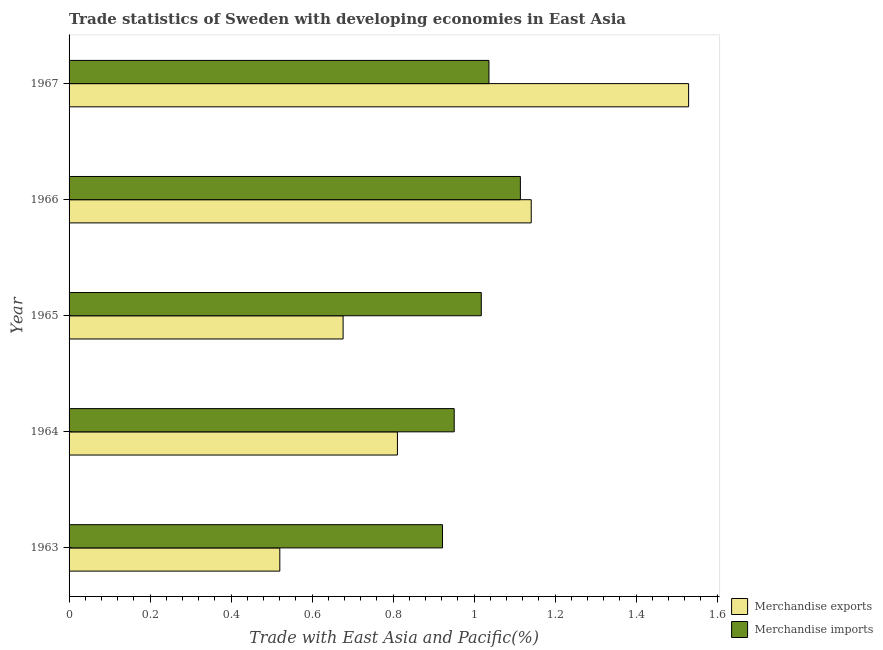Are the number of bars per tick equal to the number of legend labels?
Offer a terse response. Yes. Are the number of bars on each tick of the Y-axis equal?
Ensure brevity in your answer.  Yes. How many bars are there on the 4th tick from the top?
Give a very brief answer. 2. How many bars are there on the 2nd tick from the bottom?
Offer a terse response. 2. What is the label of the 3rd group of bars from the top?
Offer a terse response. 1965. What is the merchandise imports in 1966?
Your response must be concise. 1.11. Across all years, what is the maximum merchandise imports?
Provide a succinct answer. 1.11. Across all years, what is the minimum merchandise imports?
Make the answer very short. 0.92. In which year was the merchandise exports maximum?
Ensure brevity in your answer.  1967. What is the total merchandise exports in the graph?
Give a very brief answer. 4.68. What is the difference between the merchandise exports in 1964 and that in 1967?
Provide a succinct answer. -0.72. What is the difference between the merchandise imports in 1967 and the merchandise exports in 1963?
Make the answer very short. 0.52. What is the average merchandise exports per year?
Make the answer very short. 0.94. In the year 1964, what is the difference between the merchandise exports and merchandise imports?
Keep it short and to the point. -0.14. In how many years, is the merchandise imports greater than 0.4 %?
Your response must be concise. 5. What is the ratio of the merchandise exports in 1963 to that in 1966?
Ensure brevity in your answer.  0.46. Is the difference between the merchandise imports in 1963 and 1964 greater than the difference between the merchandise exports in 1963 and 1964?
Make the answer very short. Yes. What is the difference between the highest and the second highest merchandise imports?
Offer a terse response. 0.08. Is the sum of the merchandise imports in 1964 and 1967 greater than the maximum merchandise exports across all years?
Your answer should be very brief. Yes. What does the 2nd bar from the top in 1967 represents?
Your answer should be very brief. Merchandise exports. What does the 1st bar from the bottom in 1967 represents?
Provide a short and direct response. Merchandise exports. How many years are there in the graph?
Ensure brevity in your answer.  5. Does the graph contain grids?
Your answer should be compact. No. Where does the legend appear in the graph?
Offer a very short reply. Bottom right. How are the legend labels stacked?
Provide a succinct answer. Vertical. What is the title of the graph?
Your response must be concise. Trade statistics of Sweden with developing economies in East Asia. Does "Urban Population" appear as one of the legend labels in the graph?
Make the answer very short. No. What is the label or title of the X-axis?
Provide a short and direct response. Trade with East Asia and Pacific(%). What is the label or title of the Y-axis?
Your answer should be very brief. Year. What is the Trade with East Asia and Pacific(%) of Merchandise exports in 1963?
Offer a terse response. 0.52. What is the Trade with East Asia and Pacific(%) in Merchandise imports in 1963?
Give a very brief answer. 0.92. What is the Trade with East Asia and Pacific(%) in Merchandise exports in 1964?
Keep it short and to the point. 0.81. What is the Trade with East Asia and Pacific(%) in Merchandise imports in 1964?
Offer a terse response. 0.95. What is the Trade with East Asia and Pacific(%) in Merchandise exports in 1965?
Offer a terse response. 0.68. What is the Trade with East Asia and Pacific(%) of Merchandise imports in 1965?
Your answer should be compact. 1.02. What is the Trade with East Asia and Pacific(%) of Merchandise exports in 1966?
Provide a succinct answer. 1.14. What is the Trade with East Asia and Pacific(%) of Merchandise imports in 1966?
Offer a terse response. 1.11. What is the Trade with East Asia and Pacific(%) of Merchandise exports in 1967?
Make the answer very short. 1.53. What is the Trade with East Asia and Pacific(%) in Merchandise imports in 1967?
Offer a very short reply. 1.04. Across all years, what is the maximum Trade with East Asia and Pacific(%) in Merchandise exports?
Provide a succinct answer. 1.53. Across all years, what is the maximum Trade with East Asia and Pacific(%) of Merchandise imports?
Give a very brief answer. 1.11. Across all years, what is the minimum Trade with East Asia and Pacific(%) in Merchandise exports?
Keep it short and to the point. 0.52. Across all years, what is the minimum Trade with East Asia and Pacific(%) of Merchandise imports?
Your answer should be compact. 0.92. What is the total Trade with East Asia and Pacific(%) of Merchandise exports in the graph?
Provide a short and direct response. 4.68. What is the total Trade with East Asia and Pacific(%) of Merchandise imports in the graph?
Give a very brief answer. 5.04. What is the difference between the Trade with East Asia and Pacific(%) of Merchandise exports in 1963 and that in 1964?
Provide a succinct answer. -0.29. What is the difference between the Trade with East Asia and Pacific(%) of Merchandise imports in 1963 and that in 1964?
Make the answer very short. -0.03. What is the difference between the Trade with East Asia and Pacific(%) in Merchandise exports in 1963 and that in 1965?
Give a very brief answer. -0.16. What is the difference between the Trade with East Asia and Pacific(%) of Merchandise imports in 1963 and that in 1965?
Your answer should be very brief. -0.1. What is the difference between the Trade with East Asia and Pacific(%) of Merchandise exports in 1963 and that in 1966?
Ensure brevity in your answer.  -0.62. What is the difference between the Trade with East Asia and Pacific(%) in Merchandise imports in 1963 and that in 1966?
Give a very brief answer. -0.19. What is the difference between the Trade with East Asia and Pacific(%) in Merchandise exports in 1963 and that in 1967?
Your answer should be compact. -1.01. What is the difference between the Trade with East Asia and Pacific(%) of Merchandise imports in 1963 and that in 1967?
Provide a short and direct response. -0.11. What is the difference between the Trade with East Asia and Pacific(%) of Merchandise exports in 1964 and that in 1965?
Your response must be concise. 0.13. What is the difference between the Trade with East Asia and Pacific(%) in Merchandise imports in 1964 and that in 1965?
Ensure brevity in your answer.  -0.07. What is the difference between the Trade with East Asia and Pacific(%) of Merchandise exports in 1964 and that in 1966?
Provide a short and direct response. -0.33. What is the difference between the Trade with East Asia and Pacific(%) of Merchandise imports in 1964 and that in 1966?
Offer a very short reply. -0.16. What is the difference between the Trade with East Asia and Pacific(%) of Merchandise exports in 1964 and that in 1967?
Your answer should be very brief. -0.72. What is the difference between the Trade with East Asia and Pacific(%) of Merchandise imports in 1964 and that in 1967?
Provide a short and direct response. -0.09. What is the difference between the Trade with East Asia and Pacific(%) of Merchandise exports in 1965 and that in 1966?
Make the answer very short. -0.46. What is the difference between the Trade with East Asia and Pacific(%) of Merchandise imports in 1965 and that in 1966?
Provide a short and direct response. -0.1. What is the difference between the Trade with East Asia and Pacific(%) of Merchandise exports in 1965 and that in 1967?
Provide a succinct answer. -0.85. What is the difference between the Trade with East Asia and Pacific(%) of Merchandise imports in 1965 and that in 1967?
Ensure brevity in your answer.  -0.02. What is the difference between the Trade with East Asia and Pacific(%) of Merchandise exports in 1966 and that in 1967?
Provide a short and direct response. -0.39. What is the difference between the Trade with East Asia and Pacific(%) of Merchandise imports in 1966 and that in 1967?
Make the answer very short. 0.08. What is the difference between the Trade with East Asia and Pacific(%) of Merchandise exports in 1963 and the Trade with East Asia and Pacific(%) of Merchandise imports in 1964?
Ensure brevity in your answer.  -0.43. What is the difference between the Trade with East Asia and Pacific(%) in Merchandise exports in 1963 and the Trade with East Asia and Pacific(%) in Merchandise imports in 1965?
Keep it short and to the point. -0.5. What is the difference between the Trade with East Asia and Pacific(%) of Merchandise exports in 1963 and the Trade with East Asia and Pacific(%) of Merchandise imports in 1966?
Make the answer very short. -0.59. What is the difference between the Trade with East Asia and Pacific(%) of Merchandise exports in 1963 and the Trade with East Asia and Pacific(%) of Merchandise imports in 1967?
Provide a succinct answer. -0.52. What is the difference between the Trade with East Asia and Pacific(%) in Merchandise exports in 1964 and the Trade with East Asia and Pacific(%) in Merchandise imports in 1965?
Provide a succinct answer. -0.21. What is the difference between the Trade with East Asia and Pacific(%) of Merchandise exports in 1964 and the Trade with East Asia and Pacific(%) of Merchandise imports in 1966?
Provide a short and direct response. -0.3. What is the difference between the Trade with East Asia and Pacific(%) of Merchandise exports in 1964 and the Trade with East Asia and Pacific(%) of Merchandise imports in 1967?
Ensure brevity in your answer.  -0.23. What is the difference between the Trade with East Asia and Pacific(%) in Merchandise exports in 1965 and the Trade with East Asia and Pacific(%) in Merchandise imports in 1966?
Provide a short and direct response. -0.44. What is the difference between the Trade with East Asia and Pacific(%) in Merchandise exports in 1965 and the Trade with East Asia and Pacific(%) in Merchandise imports in 1967?
Offer a very short reply. -0.36. What is the difference between the Trade with East Asia and Pacific(%) of Merchandise exports in 1966 and the Trade with East Asia and Pacific(%) of Merchandise imports in 1967?
Offer a very short reply. 0.1. What is the average Trade with East Asia and Pacific(%) in Merchandise exports per year?
Provide a short and direct response. 0.94. What is the average Trade with East Asia and Pacific(%) in Merchandise imports per year?
Offer a terse response. 1.01. In the year 1963, what is the difference between the Trade with East Asia and Pacific(%) in Merchandise exports and Trade with East Asia and Pacific(%) in Merchandise imports?
Provide a succinct answer. -0.4. In the year 1964, what is the difference between the Trade with East Asia and Pacific(%) of Merchandise exports and Trade with East Asia and Pacific(%) of Merchandise imports?
Give a very brief answer. -0.14. In the year 1965, what is the difference between the Trade with East Asia and Pacific(%) of Merchandise exports and Trade with East Asia and Pacific(%) of Merchandise imports?
Offer a terse response. -0.34. In the year 1966, what is the difference between the Trade with East Asia and Pacific(%) in Merchandise exports and Trade with East Asia and Pacific(%) in Merchandise imports?
Offer a very short reply. 0.03. In the year 1967, what is the difference between the Trade with East Asia and Pacific(%) in Merchandise exports and Trade with East Asia and Pacific(%) in Merchandise imports?
Offer a terse response. 0.49. What is the ratio of the Trade with East Asia and Pacific(%) in Merchandise exports in 1963 to that in 1964?
Provide a succinct answer. 0.64. What is the ratio of the Trade with East Asia and Pacific(%) in Merchandise imports in 1963 to that in 1964?
Make the answer very short. 0.97. What is the ratio of the Trade with East Asia and Pacific(%) in Merchandise exports in 1963 to that in 1965?
Provide a short and direct response. 0.77. What is the ratio of the Trade with East Asia and Pacific(%) in Merchandise imports in 1963 to that in 1965?
Give a very brief answer. 0.91. What is the ratio of the Trade with East Asia and Pacific(%) of Merchandise exports in 1963 to that in 1966?
Your response must be concise. 0.46. What is the ratio of the Trade with East Asia and Pacific(%) in Merchandise imports in 1963 to that in 1966?
Make the answer very short. 0.83. What is the ratio of the Trade with East Asia and Pacific(%) of Merchandise exports in 1963 to that in 1967?
Make the answer very short. 0.34. What is the ratio of the Trade with East Asia and Pacific(%) of Merchandise imports in 1963 to that in 1967?
Your answer should be very brief. 0.89. What is the ratio of the Trade with East Asia and Pacific(%) in Merchandise exports in 1964 to that in 1965?
Keep it short and to the point. 1.2. What is the ratio of the Trade with East Asia and Pacific(%) of Merchandise imports in 1964 to that in 1965?
Your answer should be compact. 0.93. What is the ratio of the Trade with East Asia and Pacific(%) of Merchandise exports in 1964 to that in 1966?
Provide a short and direct response. 0.71. What is the ratio of the Trade with East Asia and Pacific(%) of Merchandise imports in 1964 to that in 1966?
Offer a terse response. 0.85. What is the ratio of the Trade with East Asia and Pacific(%) of Merchandise exports in 1964 to that in 1967?
Your answer should be compact. 0.53. What is the ratio of the Trade with East Asia and Pacific(%) of Merchandise imports in 1964 to that in 1967?
Your answer should be compact. 0.92. What is the ratio of the Trade with East Asia and Pacific(%) in Merchandise exports in 1965 to that in 1966?
Ensure brevity in your answer.  0.59. What is the ratio of the Trade with East Asia and Pacific(%) in Merchandise imports in 1965 to that in 1966?
Keep it short and to the point. 0.91. What is the ratio of the Trade with East Asia and Pacific(%) of Merchandise exports in 1965 to that in 1967?
Provide a succinct answer. 0.44. What is the ratio of the Trade with East Asia and Pacific(%) in Merchandise imports in 1965 to that in 1967?
Ensure brevity in your answer.  0.98. What is the ratio of the Trade with East Asia and Pacific(%) of Merchandise exports in 1966 to that in 1967?
Keep it short and to the point. 0.75. What is the ratio of the Trade with East Asia and Pacific(%) of Merchandise imports in 1966 to that in 1967?
Offer a terse response. 1.07. What is the difference between the highest and the second highest Trade with East Asia and Pacific(%) in Merchandise exports?
Ensure brevity in your answer.  0.39. What is the difference between the highest and the second highest Trade with East Asia and Pacific(%) of Merchandise imports?
Give a very brief answer. 0.08. What is the difference between the highest and the lowest Trade with East Asia and Pacific(%) in Merchandise exports?
Your answer should be very brief. 1.01. What is the difference between the highest and the lowest Trade with East Asia and Pacific(%) of Merchandise imports?
Provide a short and direct response. 0.19. 